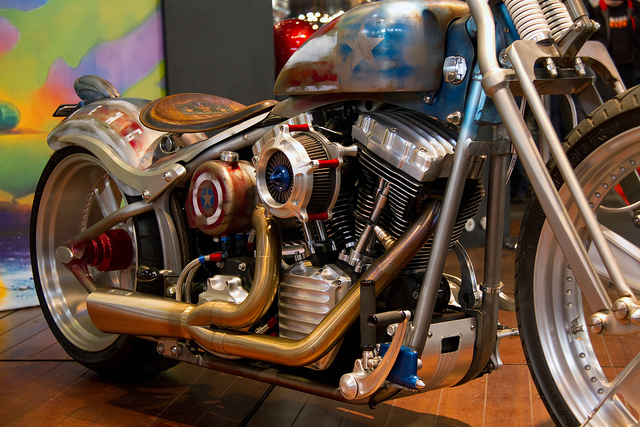Identify and read out the text in this image. O 